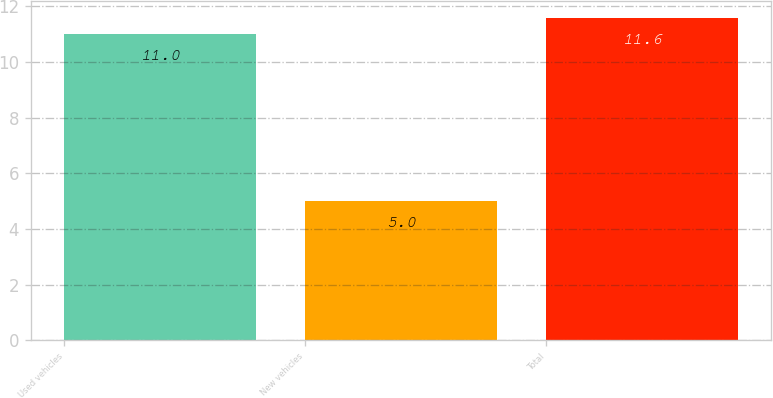<chart> <loc_0><loc_0><loc_500><loc_500><bar_chart><fcel>Used vehicles<fcel>New vehicles<fcel>Total<nl><fcel>11<fcel>5<fcel>11.6<nl></chart> 